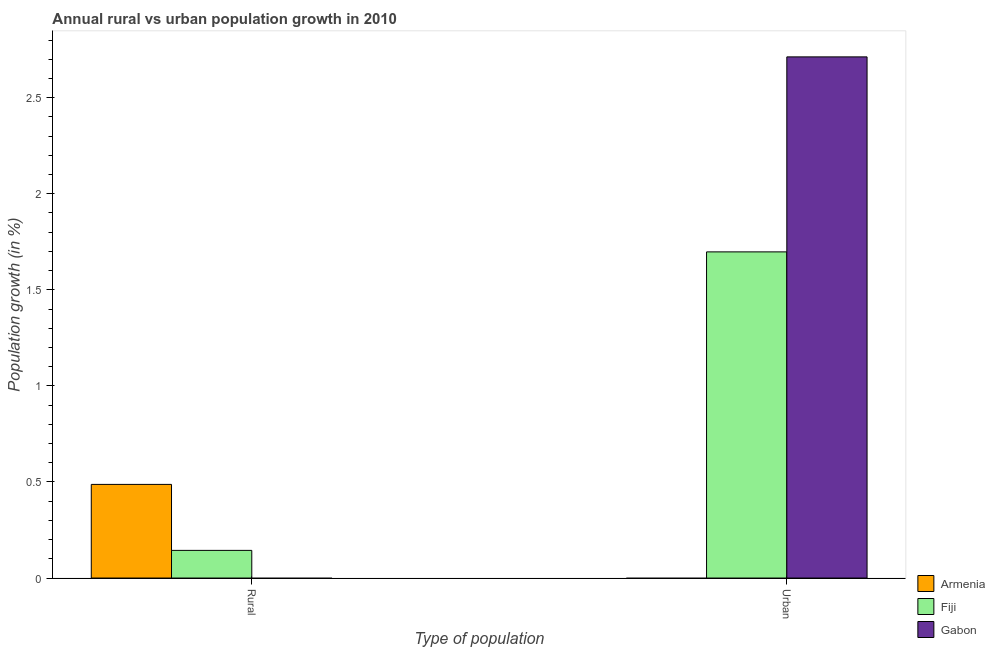Are the number of bars on each tick of the X-axis equal?
Your answer should be compact. Yes. How many bars are there on the 2nd tick from the left?
Make the answer very short. 2. How many bars are there on the 1st tick from the right?
Provide a succinct answer. 2. What is the label of the 2nd group of bars from the left?
Your response must be concise. Urban . What is the rural population growth in Fiji?
Your answer should be very brief. 0.14. Across all countries, what is the maximum rural population growth?
Ensure brevity in your answer.  0.49. Across all countries, what is the minimum rural population growth?
Your response must be concise. 0. In which country was the urban population growth maximum?
Give a very brief answer. Gabon. What is the total rural population growth in the graph?
Make the answer very short. 0.63. What is the difference between the urban population growth in Gabon and that in Fiji?
Make the answer very short. 1.01. What is the difference between the urban population growth in Fiji and the rural population growth in Gabon?
Your answer should be compact. 1.7. What is the average urban population growth per country?
Offer a terse response. 1.47. Is the urban population growth in Gabon less than that in Fiji?
Your answer should be very brief. No. Are all the bars in the graph horizontal?
Ensure brevity in your answer.  No. What is the difference between two consecutive major ticks on the Y-axis?
Provide a succinct answer. 0.5. Does the graph contain any zero values?
Make the answer very short. Yes. Does the graph contain grids?
Provide a succinct answer. No. Where does the legend appear in the graph?
Your response must be concise. Bottom right. How many legend labels are there?
Your answer should be compact. 3. How are the legend labels stacked?
Give a very brief answer. Vertical. What is the title of the graph?
Offer a terse response. Annual rural vs urban population growth in 2010. Does "Eritrea" appear as one of the legend labels in the graph?
Provide a succinct answer. No. What is the label or title of the X-axis?
Keep it short and to the point. Type of population. What is the label or title of the Y-axis?
Keep it short and to the point. Population growth (in %). What is the Population growth (in %) of Armenia in Rural?
Keep it short and to the point. 0.49. What is the Population growth (in %) of Fiji in Rural?
Offer a terse response. 0.14. What is the Population growth (in %) of Armenia in Urban ?
Offer a terse response. 0. What is the Population growth (in %) of Fiji in Urban ?
Give a very brief answer. 1.7. What is the Population growth (in %) of Gabon in Urban ?
Provide a short and direct response. 2.71. Across all Type of population, what is the maximum Population growth (in %) in Armenia?
Offer a terse response. 0.49. Across all Type of population, what is the maximum Population growth (in %) in Fiji?
Provide a short and direct response. 1.7. Across all Type of population, what is the maximum Population growth (in %) of Gabon?
Make the answer very short. 2.71. Across all Type of population, what is the minimum Population growth (in %) in Armenia?
Offer a terse response. 0. Across all Type of population, what is the minimum Population growth (in %) of Fiji?
Provide a succinct answer. 0.14. Across all Type of population, what is the minimum Population growth (in %) of Gabon?
Offer a terse response. 0. What is the total Population growth (in %) in Armenia in the graph?
Offer a terse response. 0.49. What is the total Population growth (in %) in Fiji in the graph?
Your answer should be compact. 1.84. What is the total Population growth (in %) of Gabon in the graph?
Provide a succinct answer. 2.71. What is the difference between the Population growth (in %) of Fiji in Rural and that in Urban ?
Your answer should be very brief. -1.55. What is the difference between the Population growth (in %) in Armenia in Rural and the Population growth (in %) in Fiji in Urban?
Your answer should be very brief. -1.21. What is the difference between the Population growth (in %) in Armenia in Rural and the Population growth (in %) in Gabon in Urban?
Make the answer very short. -2.23. What is the difference between the Population growth (in %) in Fiji in Rural and the Population growth (in %) in Gabon in Urban?
Offer a very short reply. -2.57. What is the average Population growth (in %) in Armenia per Type of population?
Give a very brief answer. 0.24. What is the average Population growth (in %) in Fiji per Type of population?
Give a very brief answer. 0.92. What is the average Population growth (in %) in Gabon per Type of population?
Offer a very short reply. 1.36. What is the difference between the Population growth (in %) in Armenia and Population growth (in %) in Fiji in Rural?
Make the answer very short. 0.34. What is the difference between the Population growth (in %) in Fiji and Population growth (in %) in Gabon in Urban ?
Your answer should be very brief. -1.01. What is the ratio of the Population growth (in %) of Fiji in Rural to that in Urban ?
Your answer should be very brief. 0.08. What is the difference between the highest and the second highest Population growth (in %) of Fiji?
Your answer should be compact. 1.55. What is the difference between the highest and the lowest Population growth (in %) of Armenia?
Your answer should be very brief. 0.49. What is the difference between the highest and the lowest Population growth (in %) in Fiji?
Keep it short and to the point. 1.55. What is the difference between the highest and the lowest Population growth (in %) of Gabon?
Make the answer very short. 2.71. 